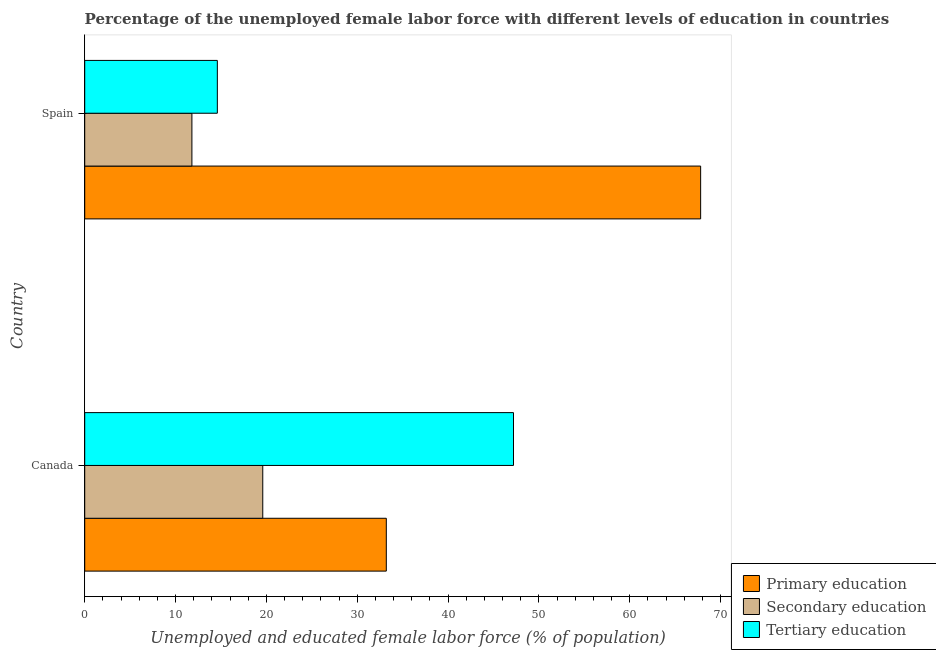How many different coloured bars are there?
Offer a terse response. 3. How many groups of bars are there?
Keep it short and to the point. 2. Are the number of bars on each tick of the Y-axis equal?
Your response must be concise. Yes. In how many cases, is the number of bars for a given country not equal to the number of legend labels?
Offer a very short reply. 0. What is the percentage of female labor force who received primary education in Spain?
Provide a short and direct response. 67.8. Across all countries, what is the maximum percentage of female labor force who received primary education?
Keep it short and to the point. 67.8. Across all countries, what is the minimum percentage of female labor force who received tertiary education?
Offer a very short reply. 14.6. In which country was the percentage of female labor force who received tertiary education maximum?
Your answer should be compact. Canada. What is the total percentage of female labor force who received tertiary education in the graph?
Make the answer very short. 61.8. What is the difference between the percentage of female labor force who received primary education in Canada and that in Spain?
Make the answer very short. -34.6. What is the difference between the percentage of female labor force who received secondary education in Canada and the percentage of female labor force who received tertiary education in Spain?
Provide a succinct answer. 5. What is the average percentage of female labor force who received tertiary education per country?
Ensure brevity in your answer.  30.9. In how many countries, is the percentage of female labor force who received primary education greater than 22 %?
Offer a terse response. 2. What is the ratio of the percentage of female labor force who received primary education in Canada to that in Spain?
Provide a short and direct response. 0.49. Is the percentage of female labor force who received primary education in Canada less than that in Spain?
Your answer should be very brief. Yes. In how many countries, is the percentage of female labor force who received primary education greater than the average percentage of female labor force who received primary education taken over all countries?
Ensure brevity in your answer.  1. Are all the bars in the graph horizontal?
Make the answer very short. Yes. What is the difference between two consecutive major ticks on the X-axis?
Offer a very short reply. 10. Are the values on the major ticks of X-axis written in scientific E-notation?
Provide a succinct answer. No. Does the graph contain any zero values?
Offer a terse response. No. How are the legend labels stacked?
Offer a terse response. Vertical. What is the title of the graph?
Your response must be concise. Percentage of the unemployed female labor force with different levels of education in countries. Does "Primary education" appear as one of the legend labels in the graph?
Provide a short and direct response. Yes. What is the label or title of the X-axis?
Your answer should be compact. Unemployed and educated female labor force (% of population). What is the label or title of the Y-axis?
Ensure brevity in your answer.  Country. What is the Unemployed and educated female labor force (% of population) of Primary education in Canada?
Offer a very short reply. 33.2. What is the Unemployed and educated female labor force (% of population) of Secondary education in Canada?
Give a very brief answer. 19.6. What is the Unemployed and educated female labor force (% of population) in Tertiary education in Canada?
Offer a very short reply. 47.2. What is the Unemployed and educated female labor force (% of population) of Primary education in Spain?
Your response must be concise. 67.8. What is the Unemployed and educated female labor force (% of population) in Secondary education in Spain?
Your answer should be compact. 11.8. What is the Unemployed and educated female labor force (% of population) in Tertiary education in Spain?
Provide a succinct answer. 14.6. Across all countries, what is the maximum Unemployed and educated female labor force (% of population) of Primary education?
Provide a short and direct response. 67.8. Across all countries, what is the maximum Unemployed and educated female labor force (% of population) of Secondary education?
Give a very brief answer. 19.6. Across all countries, what is the maximum Unemployed and educated female labor force (% of population) in Tertiary education?
Provide a short and direct response. 47.2. Across all countries, what is the minimum Unemployed and educated female labor force (% of population) of Primary education?
Your answer should be compact. 33.2. Across all countries, what is the minimum Unemployed and educated female labor force (% of population) of Secondary education?
Make the answer very short. 11.8. Across all countries, what is the minimum Unemployed and educated female labor force (% of population) in Tertiary education?
Ensure brevity in your answer.  14.6. What is the total Unemployed and educated female labor force (% of population) in Primary education in the graph?
Give a very brief answer. 101. What is the total Unemployed and educated female labor force (% of population) in Secondary education in the graph?
Offer a very short reply. 31.4. What is the total Unemployed and educated female labor force (% of population) of Tertiary education in the graph?
Give a very brief answer. 61.8. What is the difference between the Unemployed and educated female labor force (% of population) of Primary education in Canada and that in Spain?
Provide a succinct answer. -34.6. What is the difference between the Unemployed and educated female labor force (% of population) of Tertiary education in Canada and that in Spain?
Your answer should be compact. 32.6. What is the difference between the Unemployed and educated female labor force (% of population) of Primary education in Canada and the Unemployed and educated female labor force (% of population) of Secondary education in Spain?
Offer a terse response. 21.4. What is the difference between the Unemployed and educated female labor force (% of population) in Secondary education in Canada and the Unemployed and educated female labor force (% of population) in Tertiary education in Spain?
Ensure brevity in your answer.  5. What is the average Unemployed and educated female labor force (% of population) of Primary education per country?
Offer a very short reply. 50.5. What is the average Unemployed and educated female labor force (% of population) in Secondary education per country?
Make the answer very short. 15.7. What is the average Unemployed and educated female labor force (% of population) of Tertiary education per country?
Your response must be concise. 30.9. What is the difference between the Unemployed and educated female labor force (% of population) of Primary education and Unemployed and educated female labor force (% of population) of Secondary education in Canada?
Ensure brevity in your answer.  13.6. What is the difference between the Unemployed and educated female labor force (% of population) of Secondary education and Unemployed and educated female labor force (% of population) of Tertiary education in Canada?
Make the answer very short. -27.6. What is the difference between the Unemployed and educated female labor force (% of population) in Primary education and Unemployed and educated female labor force (% of population) in Secondary education in Spain?
Your answer should be compact. 56. What is the difference between the Unemployed and educated female labor force (% of population) of Primary education and Unemployed and educated female labor force (% of population) of Tertiary education in Spain?
Make the answer very short. 53.2. What is the difference between the Unemployed and educated female labor force (% of population) in Secondary education and Unemployed and educated female labor force (% of population) in Tertiary education in Spain?
Your response must be concise. -2.8. What is the ratio of the Unemployed and educated female labor force (% of population) of Primary education in Canada to that in Spain?
Your answer should be compact. 0.49. What is the ratio of the Unemployed and educated female labor force (% of population) in Secondary education in Canada to that in Spain?
Your answer should be compact. 1.66. What is the ratio of the Unemployed and educated female labor force (% of population) in Tertiary education in Canada to that in Spain?
Give a very brief answer. 3.23. What is the difference between the highest and the second highest Unemployed and educated female labor force (% of population) in Primary education?
Provide a succinct answer. 34.6. What is the difference between the highest and the second highest Unemployed and educated female labor force (% of population) of Tertiary education?
Keep it short and to the point. 32.6. What is the difference between the highest and the lowest Unemployed and educated female labor force (% of population) of Primary education?
Provide a short and direct response. 34.6. What is the difference between the highest and the lowest Unemployed and educated female labor force (% of population) of Secondary education?
Give a very brief answer. 7.8. What is the difference between the highest and the lowest Unemployed and educated female labor force (% of population) in Tertiary education?
Give a very brief answer. 32.6. 